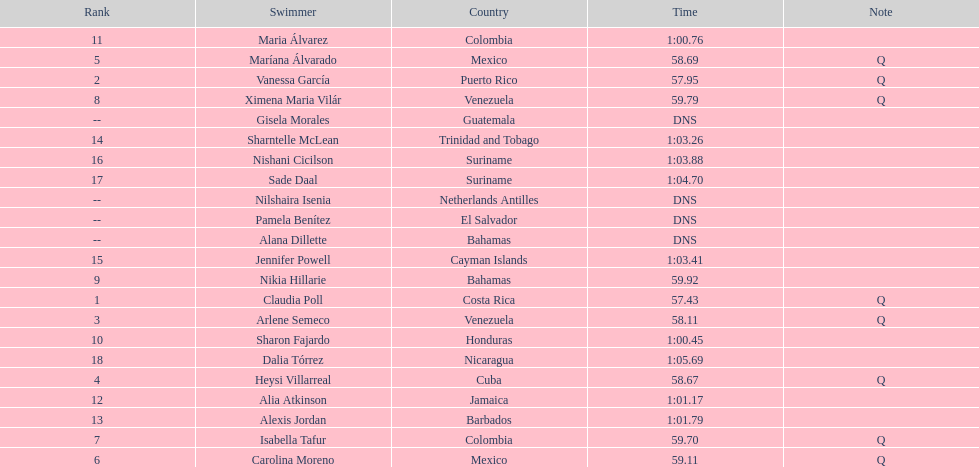Who finished after claudia poll? Vanessa García. 